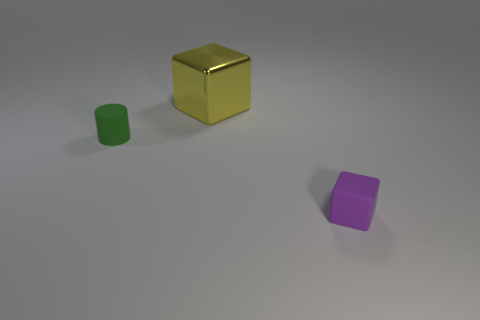Add 3 small purple rubber cubes. How many objects exist? 6 Subtract all cylinders. How many objects are left? 2 Subtract all matte things. Subtract all brown rubber balls. How many objects are left? 1 Add 2 matte blocks. How many matte blocks are left? 3 Add 2 small purple blocks. How many small purple blocks exist? 3 Subtract 1 yellow blocks. How many objects are left? 2 